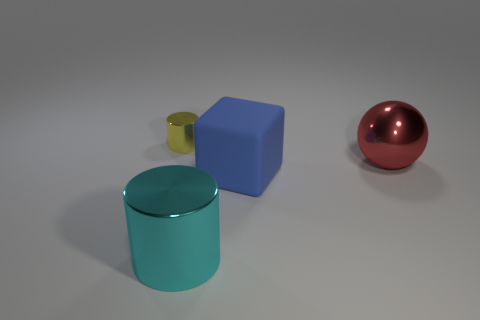Add 2 big green metallic objects. How many objects exist? 6 Subtract all cubes. How many objects are left? 3 Add 1 yellow metal objects. How many yellow metal objects are left? 2 Add 4 big cubes. How many big cubes exist? 5 Subtract 0 purple cubes. How many objects are left? 4 Subtract all big shiny cylinders. Subtract all big red things. How many objects are left? 2 